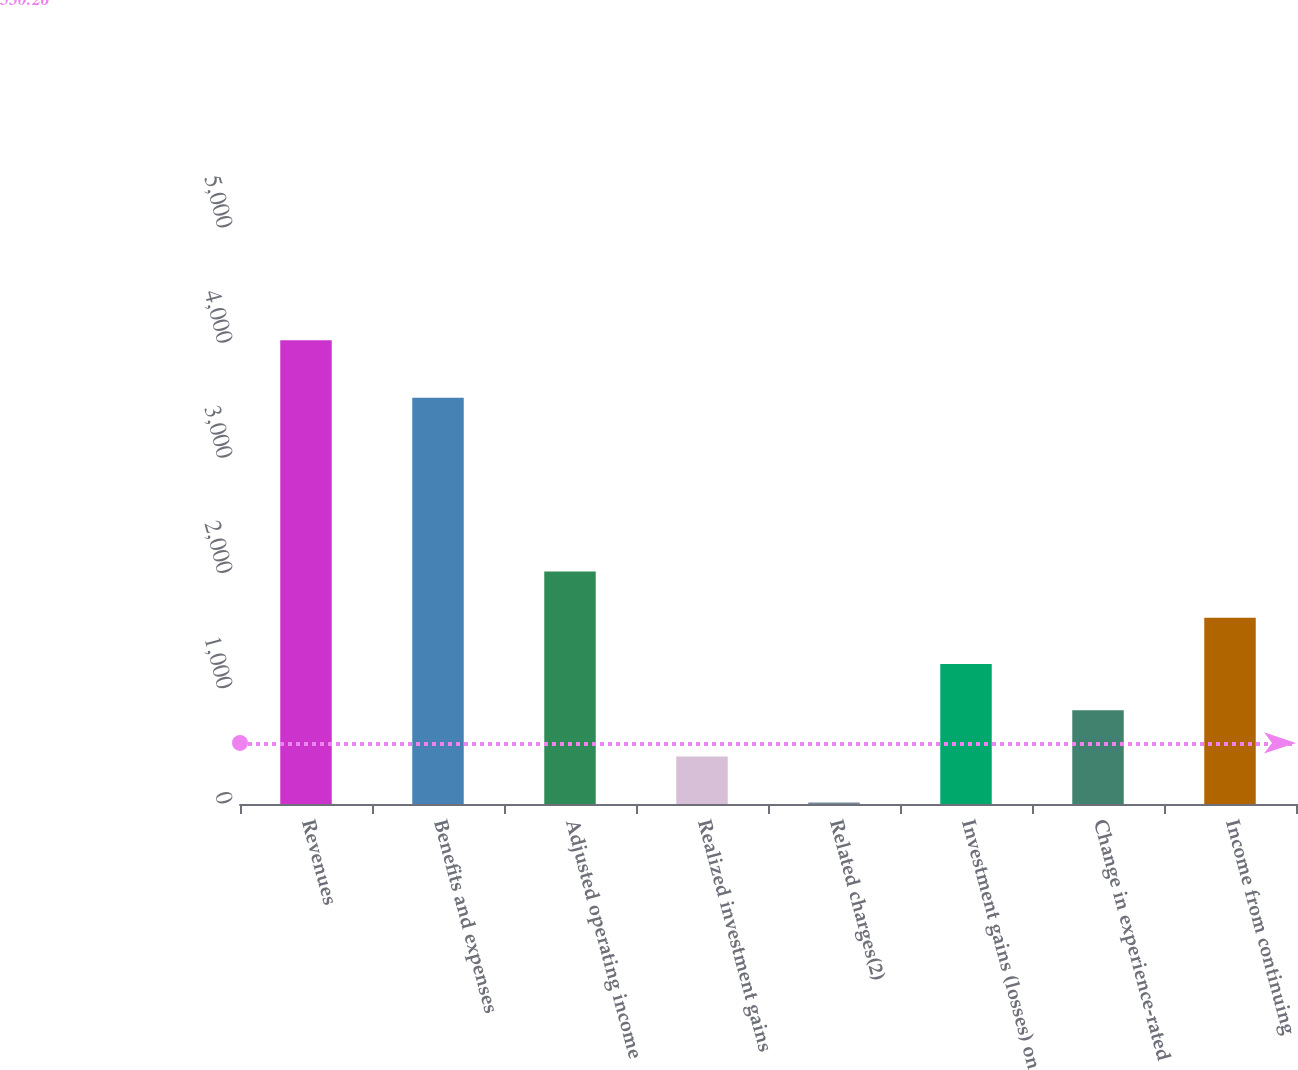Convert chart to OTSL. <chart><loc_0><loc_0><loc_500><loc_500><bar_chart><fcel>Revenues<fcel>Benefits and expenses<fcel>Adjusted operating income<fcel>Realized investment gains<fcel>Related charges(2)<fcel>Investment gains (losses) on<fcel>Change in experience-rated<fcel>Income from continuing<nl><fcel>4025<fcel>3527<fcel>2018.5<fcel>413.3<fcel>12<fcel>1215.9<fcel>814.6<fcel>1617.2<nl></chart> 